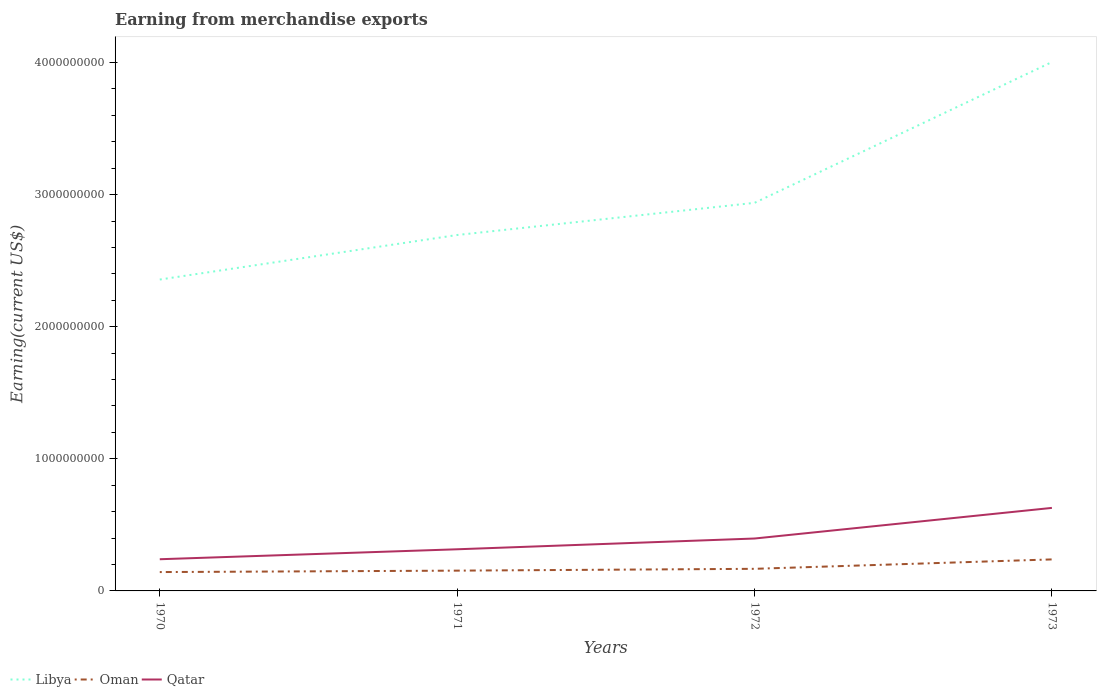Across all years, what is the maximum amount earned from merchandise exports in Qatar?
Your answer should be compact. 2.40e+08. What is the total amount earned from merchandise exports in Oman in the graph?
Ensure brevity in your answer.  -8.50e+07. What is the difference between the highest and the second highest amount earned from merchandise exports in Oman?
Offer a very short reply. 9.58e+07. What is the difference between the highest and the lowest amount earned from merchandise exports in Qatar?
Provide a short and direct response. 2. Is the amount earned from merchandise exports in Oman strictly greater than the amount earned from merchandise exports in Qatar over the years?
Your answer should be compact. Yes. How many lines are there?
Keep it short and to the point. 3. What is the difference between two consecutive major ticks on the Y-axis?
Give a very brief answer. 1.00e+09. Does the graph contain grids?
Give a very brief answer. No. How many legend labels are there?
Your answer should be compact. 3. How are the legend labels stacked?
Keep it short and to the point. Horizontal. What is the title of the graph?
Offer a terse response. Earning from merchandise exports. Does "Bahrain" appear as one of the legend labels in the graph?
Provide a succinct answer. No. What is the label or title of the X-axis?
Provide a succinct answer. Years. What is the label or title of the Y-axis?
Provide a succinct answer. Earning(current US$). What is the Earning(current US$) in Libya in 1970?
Your answer should be compact. 2.36e+09. What is the Earning(current US$) of Oman in 1970?
Keep it short and to the point. 1.43e+08. What is the Earning(current US$) in Qatar in 1970?
Make the answer very short. 2.40e+08. What is the Earning(current US$) of Libya in 1971?
Your response must be concise. 2.69e+09. What is the Earning(current US$) in Oman in 1971?
Ensure brevity in your answer.  1.54e+08. What is the Earning(current US$) in Qatar in 1971?
Your answer should be very brief. 3.15e+08. What is the Earning(current US$) of Libya in 1972?
Your answer should be very brief. 2.94e+09. What is the Earning(current US$) in Oman in 1972?
Ensure brevity in your answer.  1.67e+08. What is the Earning(current US$) of Qatar in 1972?
Your answer should be compact. 3.97e+08. What is the Earning(current US$) in Libya in 1973?
Ensure brevity in your answer.  4.00e+09. What is the Earning(current US$) in Oman in 1973?
Offer a very short reply. 2.39e+08. What is the Earning(current US$) of Qatar in 1973?
Provide a short and direct response. 6.28e+08. Across all years, what is the maximum Earning(current US$) in Libya?
Ensure brevity in your answer.  4.00e+09. Across all years, what is the maximum Earning(current US$) in Oman?
Your answer should be compact. 2.39e+08. Across all years, what is the maximum Earning(current US$) in Qatar?
Offer a very short reply. 6.28e+08. Across all years, what is the minimum Earning(current US$) in Libya?
Make the answer very short. 2.36e+09. Across all years, what is the minimum Earning(current US$) of Oman?
Make the answer very short. 1.43e+08. Across all years, what is the minimum Earning(current US$) in Qatar?
Provide a short and direct response. 2.40e+08. What is the total Earning(current US$) of Libya in the graph?
Your answer should be compact. 1.20e+1. What is the total Earning(current US$) in Oman in the graph?
Keep it short and to the point. 7.02e+08. What is the total Earning(current US$) in Qatar in the graph?
Ensure brevity in your answer.  1.58e+09. What is the difference between the Earning(current US$) in Libya in 1970 and that in 1971?
Give a very brief answer. -3.37e+08. What is the difference between the Earning(current US$) in Oman in 1970 and that in 1971?
Make the answer very short. -1.09e+07. What is the difference between the Earning(current US$) in Qatar in 1970 and that in 1971?
Keep it short and to the point. -7.53e+07. What is the difference between the Earning(current US$) in Libya in 1970 and that in 1972?
Offer a very short reply. -5.81e+08. What is the difference between the Earning(current US$) in Oman in 1970 and that in 1972?
Offer a very short reply. -2.46e+07. What is the difference between the Earning(current US$) in Qatar in 1970 and that in 1972?
Your answer should be very brief. -1.57e+08. What is the difference between the Earning(current US$) in Libya in 1970 and that in 1973?
Provide a succinct answer. -1.65e+09. What is the difference between the Earning(current US$) in Oman in 1970 and that in 1973?
Offer a very short reply. -9.58e+07. What is the difference between the Earning(current US$) in Qatar in 1970 and that in 1973?
Offer a terse response. -3.89e+08. What is the difference between the Earning(current US$) of Libya in 1971 and that in 1972?
Offer a very short reply. -2.43e+08. What is the difference between the Earning(current US$) of Oman in 1971 and that in 1972?
Your answer should be very brief. -1.37e+07. What is the difference between the Earning(current US$) in Qatar in 1971 and that in 1972?
Keep it short and to the point. -8.15e+07. What is the difference between the Earning(current US$) in Libya in 1971 and that in 1973?
Give a very brief answer. -1.31e+09. What is the difference between the Earning(current US$) in Oman in 1971 and that in 1973?
Ensure brevity in your answer.  -8.50e+07. What is the difference between the Earning(current US$) in Qatar in 1971 and that in 1973?
Keep it short and to the point. -3.13e+08. What is the difference between the Earning(current US$) in Libya in 1972 and that in 1973?
Offer a terse response. -1.07e+09. What is the difference between the Earning(current US$) of Oman in 1972 and that in 1973?
Your response must be concise. -7.12e+07. What is the difference between the Earning(current US$) in Qatar in 1972 and that in 1973?
Your answer should be very brief. -2.32e+08. What is the difference between the Earning(current US$) of Libya in 1970 and the Earning(current US$) of Oman in 1971?
Offer a very short reply. 2.20e+09. What is the difference between the Earning(current US$) in Libya in 1970 and the Earning(current US$) in Qatar in 1971?
Ensure brevity in your answer.  2.04e+09. What is the difference between the Earning(current US$) of Oman in 1970 and the Earning(current US$) of Qatar in 1971?
Give a very brief answer. -1.72e+08. What is the difference between the Earning(current US$) of Libya in 1970 and the Earning(current US$) of Oman in 1972?
Provide a short and direct response. 2.19e+09. What is the difference between the Earning(current US$) of Libya in 1970 and the Earning(current US$) of Qatar in 1972?
Provide a succinct answer. 1.96e+09. What is the difference between the Earning(current US$) of Oman in 1970 and the Earning(current US$) of Qatar in 1972?
Offer a terse response. -2.54e+08. What is the difference between the Earning(current US$) in Libya in 1970 and the Earning(current US$) in Oman in 1973?
Make the answer very short. 2.12e+09. What is the difference between the Earning(current US$) in Libya in 1970 and the Earning(current US$) in Qatar in 1973?
Make the answer very short. 1.73e+09. What is the difference between the Earning(current US$) in Oman in 1970 and the Earning(current US$) in Qatar in 1973?
Provide a succinct answer. -4.86e+08. What is the difference between the Earning(current US$) of Libya in 1971 and the Earning(current US$) of Oman in 1972?
Provide a succinct answer. 2.53e+09. What is the difference between the Earning(current US$) of Libya in 1971 and the Earning(current US$) of Qatar in 1972?
Keep it short and to the point. 2.30e+09. What is the difference between the Earning(current US$) of Oman in 1971 and the Earning(current US$) of Qatar in 1972?
Ensure brevity in your answer.  -2.43e+08. What is the difference between the Earning(current US$) of Libya in 1971 and the Earning(current US$) of Oman in 1973?
Provide a succinct answer. 2.46e+09. What is the difference between the Earning(current US$) in Libya in 1971 and the Earning(current US$) in Qatar in 1973?
Make the answer very short. 2.07e+09. What is the difference between the Earning(current US$) of Oman in 1971 and the Earning(current US$) of Qatar in 1973?
Your answer should be compact. -4.75e+08. What is the difference between the Earning(current US$) in Libya in 1972 and the Earning(current US$) in Oman in 1973?
Give a very brief answer. 2.70e+09. What is the difference between the Earning(current US$) of Libya in 1972 and the Earning(current US$) of Qatar in 1973?
Offer a very short reply. 2.31e+09. What is the difference between the Earning(current US$) of Oman in 1972 and the Earning(current US$) of Qatar in 1973?
Offer a very short reply. -4.61e+08. What is the average Earning(current US$) in Libya per year?
Provide a succinct answer. 3.00e+09. What is the average Earning(current US$) in Oman per year?
Make the answer very short. 1.76e+08. What is the average Earning(current US$) in Qatar per year?
Your answer should be compact. 3.95e+08. In the year 1970, what is the difference between the Earning(current US$) of Libya and Earning(current US$) of Oman?
Give a very brief answer. 2.21e+09. In the year 1970, what is the difference between the Earning(current US$) of Libya and Earning(current US$) of Qatar?
Ensure brevity in your answer.  2.12e+09. In the year 1970, what is the difference between the Earning(current US$) of Oman and Earning(current US$) of Qatar?
Keep it short and to the point. -9.72e+07. In the year 1971, what is the difference between the Earning(current US$) in Libya and Earning(current US$) in Oman?
Give a very brief answer. 2.54e+09. In the year 1971, what is the difference between the Earning(current US$) in Libya and Earning(current US$) in Qatar?
Your answer should be very brief. 2.38e+09. In the year 1971, what is the difference between the Earning(current US$) of Oman and Earning(current US$) of Qatar?
Offer a terse response. -1.62e+08. In the year 1972, what is the difference between the Earning(current US$) in Libya and Earning(current US$) in Oman?
Keep it short and to the point. 2.77e+09. In the year 1972, what is the difference between the Earning(current US$) in Libya and Earning(current US$) in Qatar?
Keep it short and to the point. 2.54e+09. In the year 1972, what is the difference between the Earning(current US$) of Oman and Earning(current US$) of Qatar?
Offer a very short reply. -2.29e+08. In the year 1973, what is the difference between the Earning(current US$) in Libya and Earning(current US$) in Oman?
Offer a terse response. 3.76e+09. In the year 1973, what is the difference between the Earning(current US$) in Libya and Earning(current US$) in Qatar?
Your response must be concise. 3.37e+09. In the year 1973, what is the difference between the Earning(current US$) of Oman and Earning(current US$) of Qatar?
Keep it short and to the point. -3.90e+08. What is the ratio of the Earning(current US$) in Libya in 1970 to that in 1971?
Provide a short and direct response. 0.87. What is the ratio of the Earning(current US$) of Oman in 1970 to that in 1971?
Ensure brevity in your answer.  0.93. What is the ratio of the Earning(current US$) in Qatar in 1970 to that in 1971?
Your answer should be very brief. 0.76. What is the ratio of the Earning(current US$) in Libya in 1970 to that in 1972?
Give a very brief answer. 0.8. What is the ratio of the Earning(current US$) in Oman in 1970 to that in 1972?
Your answer should be compact. 0.85. What is the ratio of the Earning(current US$) in Qatar in 1970 to that in 1972?
Offer a very short reply. 0.6. What is the ratio of the Earning(current US$) in Libya in 1970 to that in 1973?
Provide a short and direct response. 0.59. What is the ratio of the Earning(current US$) in Oman in 1970 to that in 1973?
Offer a very short reply. 0.6. What is the ratio of the Earning(current US$) of Qatar in 1970 to that in 1973?
Your response must be concise. 0.38. What is the ratio of the Earning(current US$) of Libya in 1971 to that in 1972?
Ensure brevity in your answer.  0.92. What is the ratio of the Earning(current US$) in Oman in 1971 to that in 1972?
Your answer should be compact. 0.92. What is the ratio of the Earning(current US$) in Qatar in 1971 to that in 1972?
Provide a succinct answer. 0.79. What is the ratio of the Earning(current US$) in Libya in 1971 to that in 1973?
Make the answer very short. 0.67. What is the ratio of the Earning(current US$) of Oman in 1971 to that in 1973?
Make the answer very short. 0.64. What is the ratio of the Earning(current US$) of Qatar in 1971 to that in 1973?
Offer a terse response. 0.5. What is the ratio of the Earning(current US$) of Libya in 1972 to that in 1973?
Offer a very short reply. 0.73. What is the ratio of the Earning(current US$) in Oman in 1972 to that in 1973?
Keep it short and to the point. 0.7. What is the ratio of the Earning(current US$) of Qatar in 1972 to that in 1973?
Your answer should be very brief. 0.63. What is the difference between the highest and the second highest Earning(current US$) of Libya?
Provide a short and direct response. 1.07e+09. What is the difference between the highest and the second highest Earning(current US$) in Oman?
Make the answer very short. 7.12e+07. What is the difference between the highest and the second highest Earning(current US$) of Qatar?
Provide a succinct answer. 2.32e+08. What is the difference between the highest and the lowest Earning(current US$) of Libya?
Keep it short and to the point. 1.65e+09. What is the difference between the highest and the lowest Earning(current US$) in Oman?
Make the answer very short. 9.58e+07. What is the difference between the highest and the lowest Earning(current US$) of Qatar?
Offer a very short reply. 3.89e+08. 